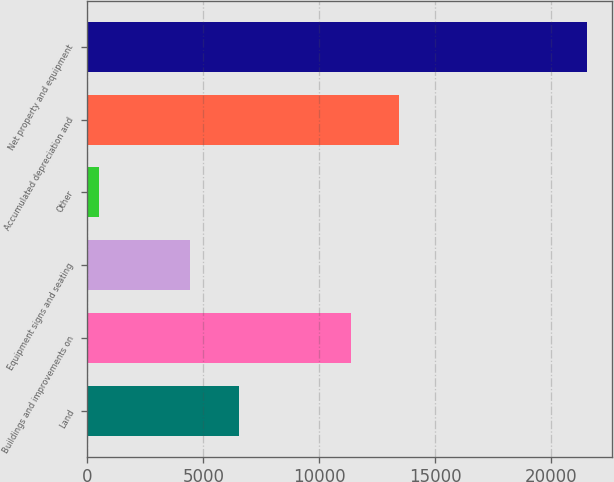<chart> <loc_0><loc_0><loc_500><loc_500><bar_chart><fcel>Land<fcel>Buildings and improvements on<fcel>Equipment signs and seating<fcel>Other<fcel>Accumulated depreciation and<fcel>Net property and equipment<nl><fcel>6525.81<fcel>11347.9<fcel>4422.9<fcel>502.4<fcel>13450.8<fcel>21531.5<nl></chart> 